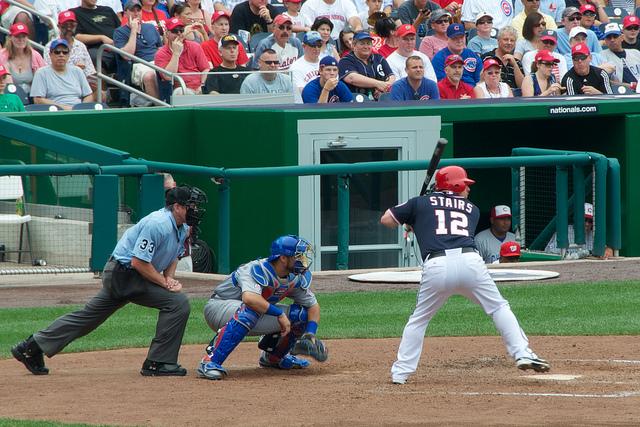Is the person in the middle playing offense or defense?
Be succinct. Defense. What number is on the umpires shirt?
Give a very brief answer. 33. What is the batter's last name?
Give a very brief answer. Stairs. 